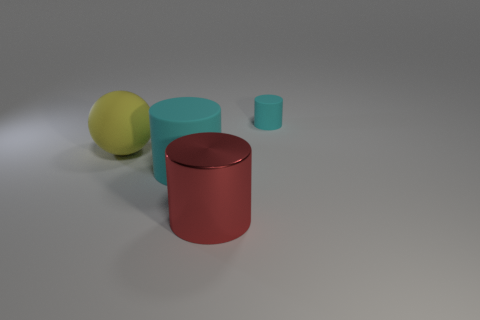What number of big metallic cylinders are in front of the tiny thing?
Keep it short and to the point. 1. Is there another metallic object that has the same size as the red shiny object?
Make the answer very short. No. Are there any spheres of the same color as the large shiny object?
Ensure brevity in your answer.  No. Is there anything else that is the same size as the red thing?
Your answer should be compact. Yes. What number of other spheres have the same color as the large matte sphere?
Your answer should be compact. 0. There is a metallic cylinder; is its color the same as the rubber cylinder that is on the left side of the large metallic cylinder?
Make the answer very short. No. How many objects are either yellow objects or things that are on the right side of the red object?
Provide a succinct answer. 2. There is a object that is on the left side of the large cylinder to the left of the red metallic thing; what is its size?
Your answer should be compact. Large. Are there an equal number of tiny cyan matte cylinders in front of the yellow rubber object and big matte objects behind the tiny thing?
Your answer should be compact. Yes. There is a cyan matte cylinder that is in front of the tiny cyan thing; is there a big cyan matte object behind it?
Offer a terse response. No. 